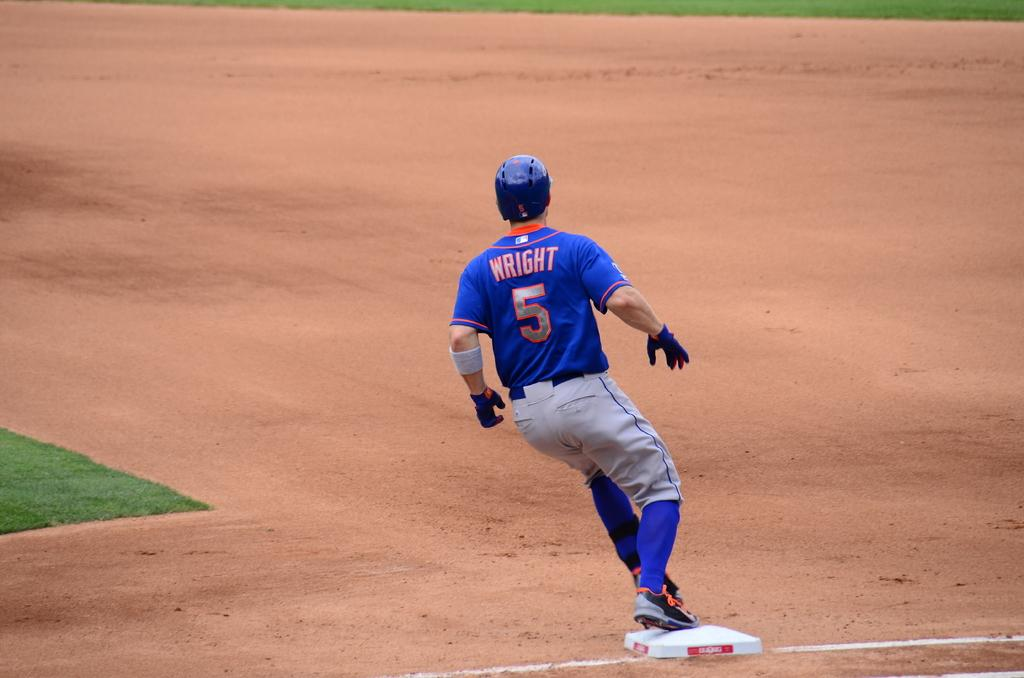<image>
Create a compact narrative representing the image presented. Baseball player wright comes up to a base and begins to stop on that same base. 